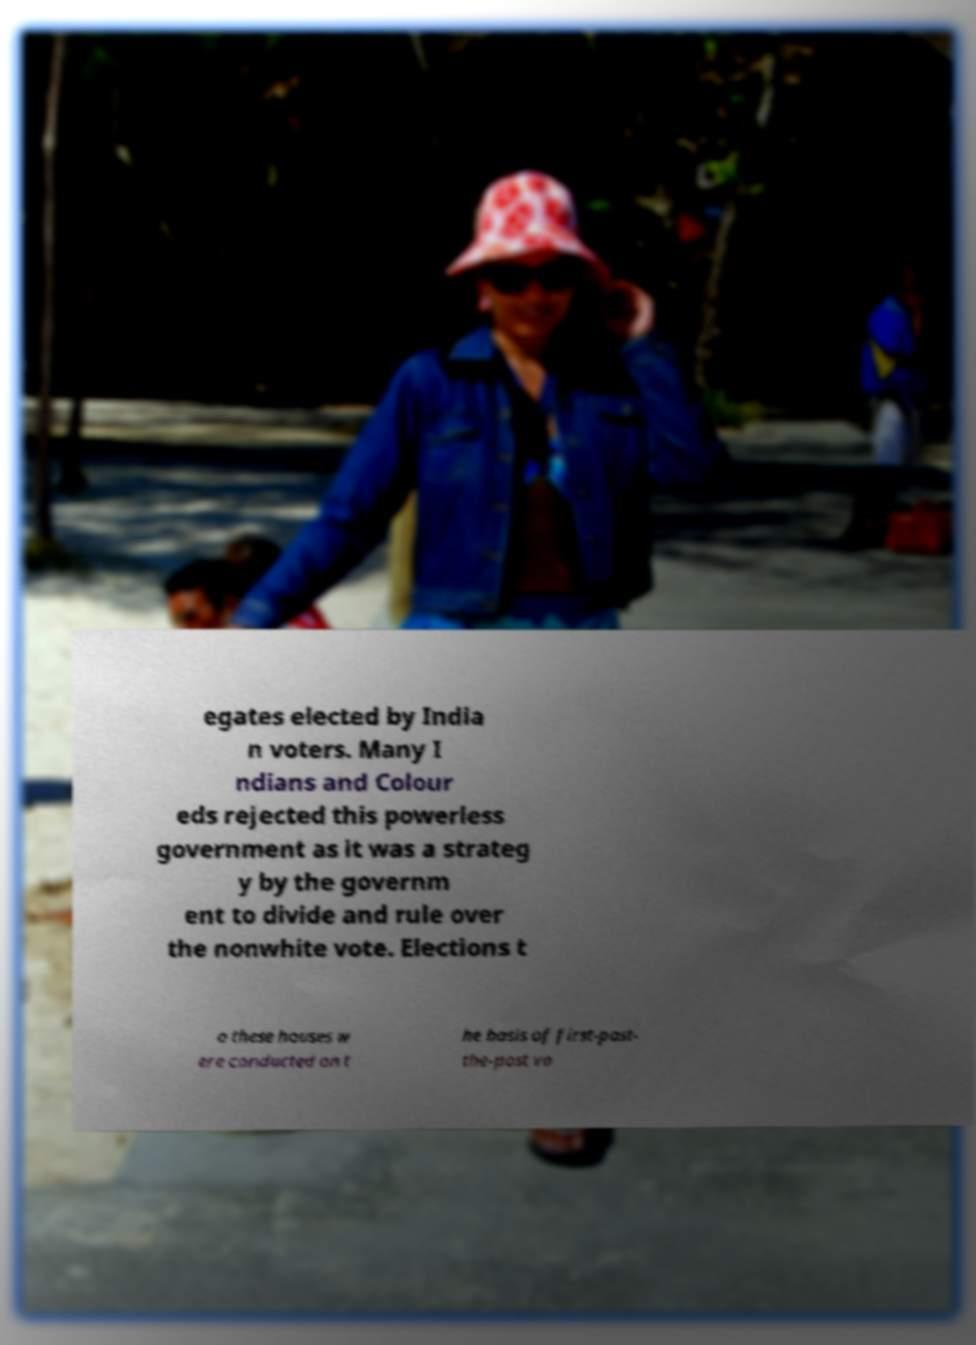Please identify and transcribe the text found in this image. egates elected by India n voters. Many I ndians and Colour eds rejected this powerless government as it was a strateg y by the governm ent to divide and rule over the nonwhite vote. Elections t o these houses w ere conducted on t he basis of first-past- the-post vo 